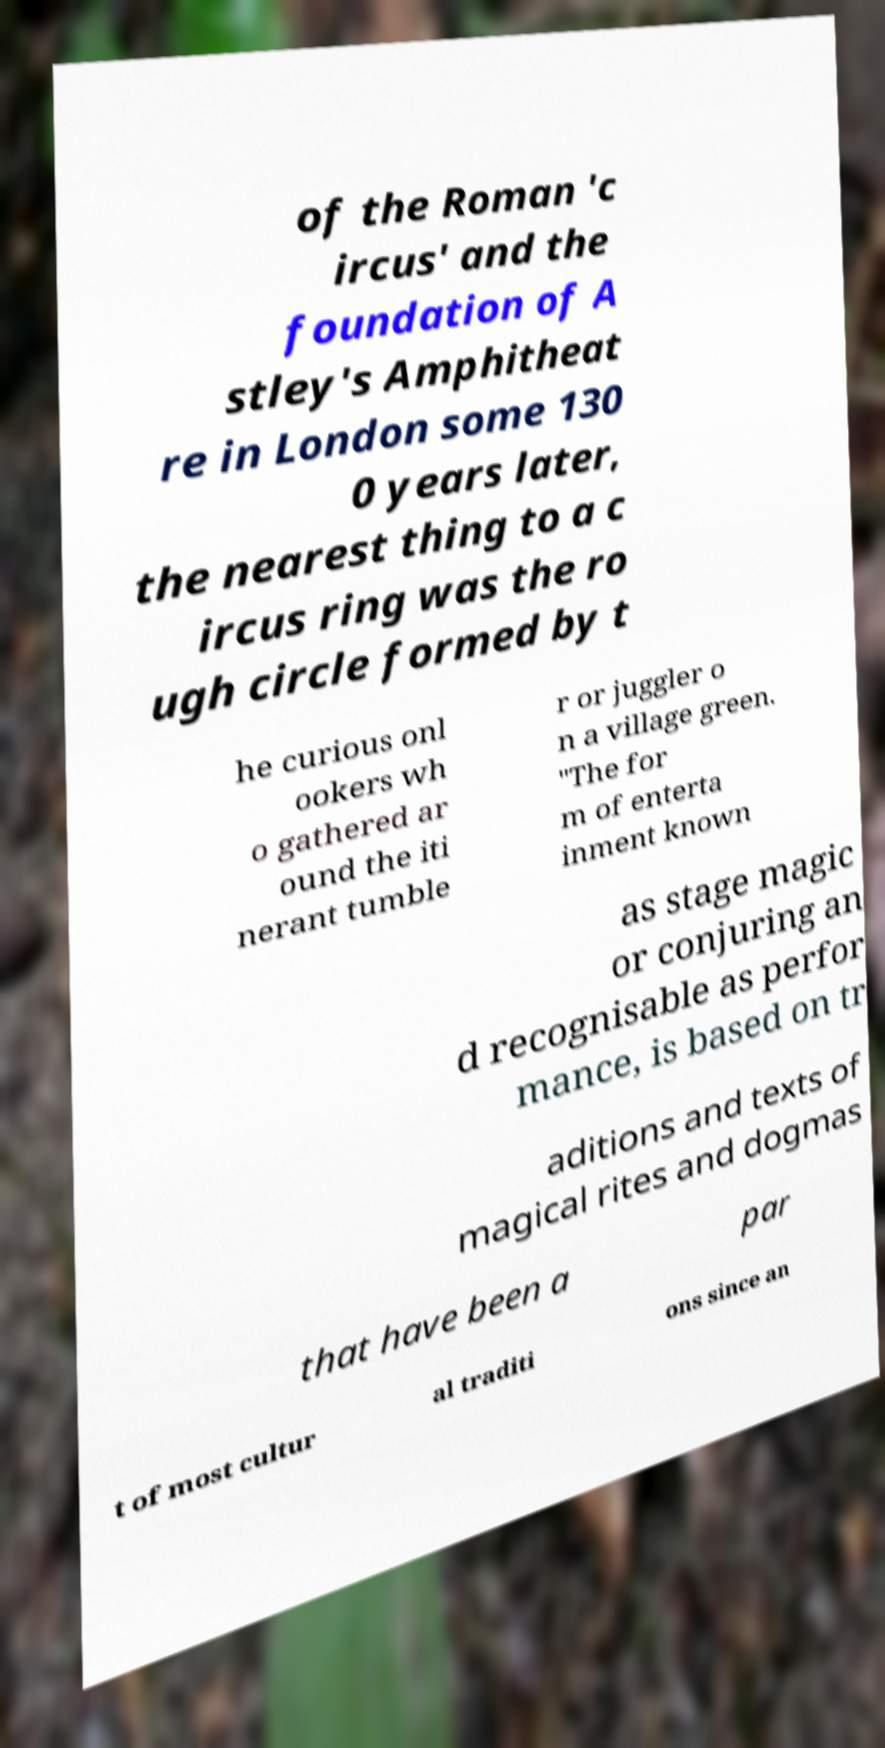Please read and relay the text visible in this image. What does it say? of the Roman 'c ircus' and the foundation of A stley's Amphitheat re in London some 130 0 years later, the nearest thing to a c ircus ring was the ro ugh circle formed by t he curious onl ookers wh o gathered ar ound the iti nerant tumble r or juggler o n a village green. "The for m of enterta inment known as stage magic or conjuring an d recognisable as perfor mance, is based on tr aditions and texts of magical rites and dogmas that have been a par t of most cultur al traditi ons since an 